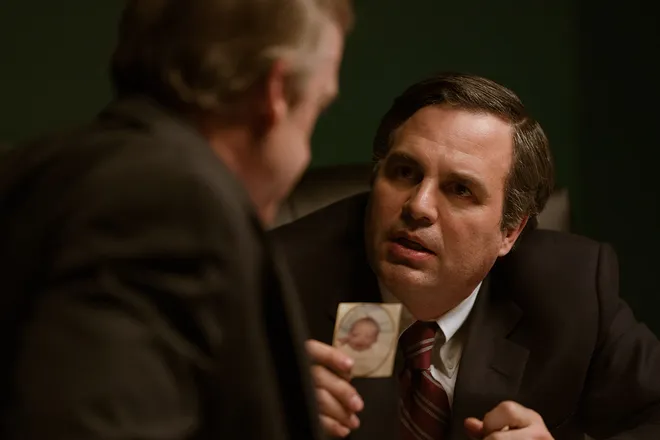Can you tell me more about the significance of the photograph being held by the man in the image? Certainly! The photograph held by the man plays a crucial role in understanding the context of the interaction. In the movie, this image represents a pivotal piece of evidence linking the health issues of community members to pollution from a large corporation. It adds a personal dimension to the legal and environmental struggle, as it likely portrays someone significantly affected by these issues. 